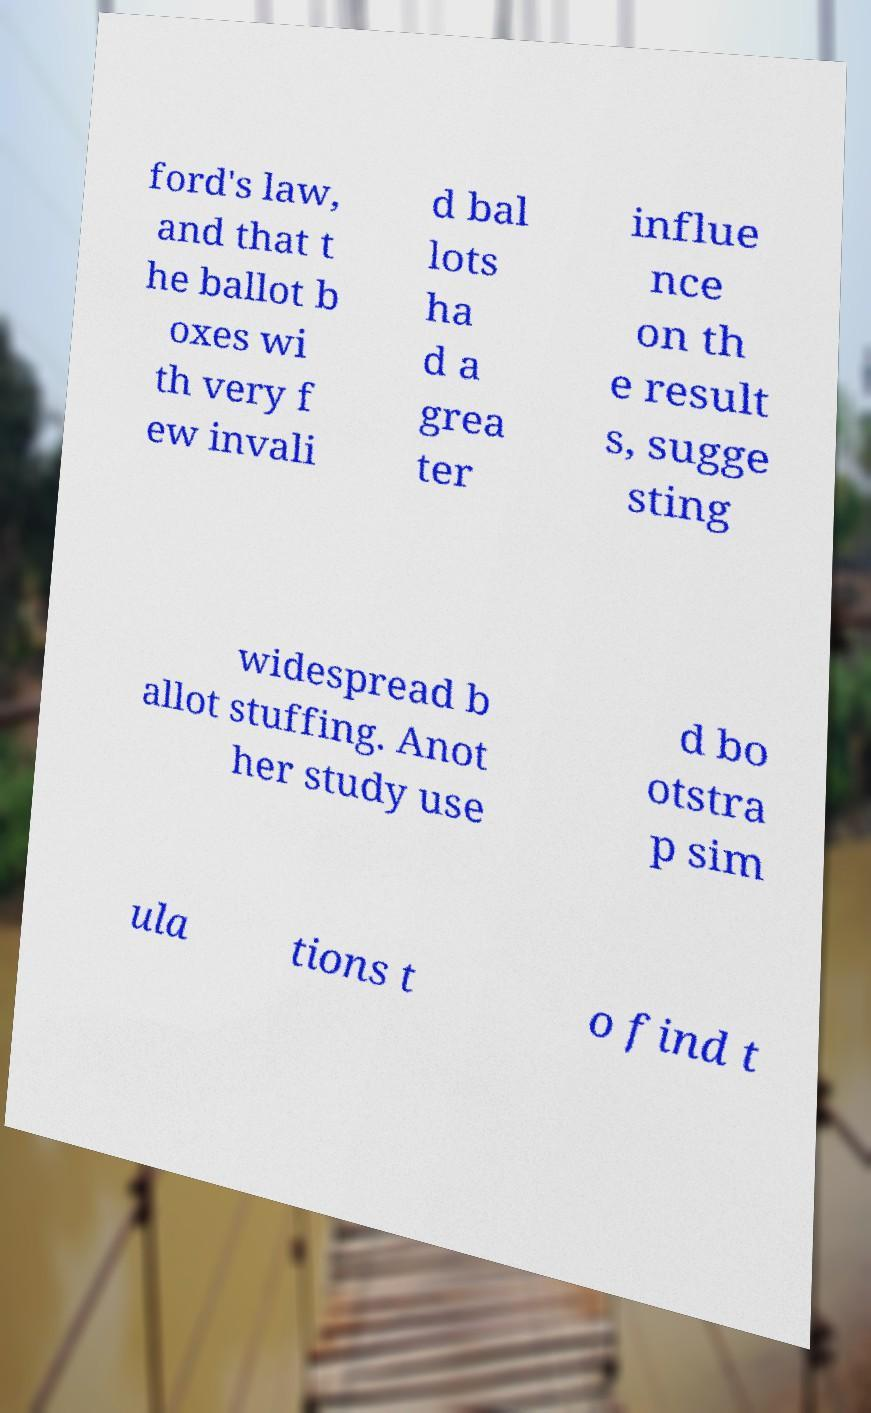Could you extract and type out the text from this image? ford's law, and that t he ballot b oxes wi th very f ew invali d bal lots ha d a grea ter influe nce on th e result s, sugge sting widespread b allot stuffing. Anot her study use d bo otstra p sim ula tions t o find t 